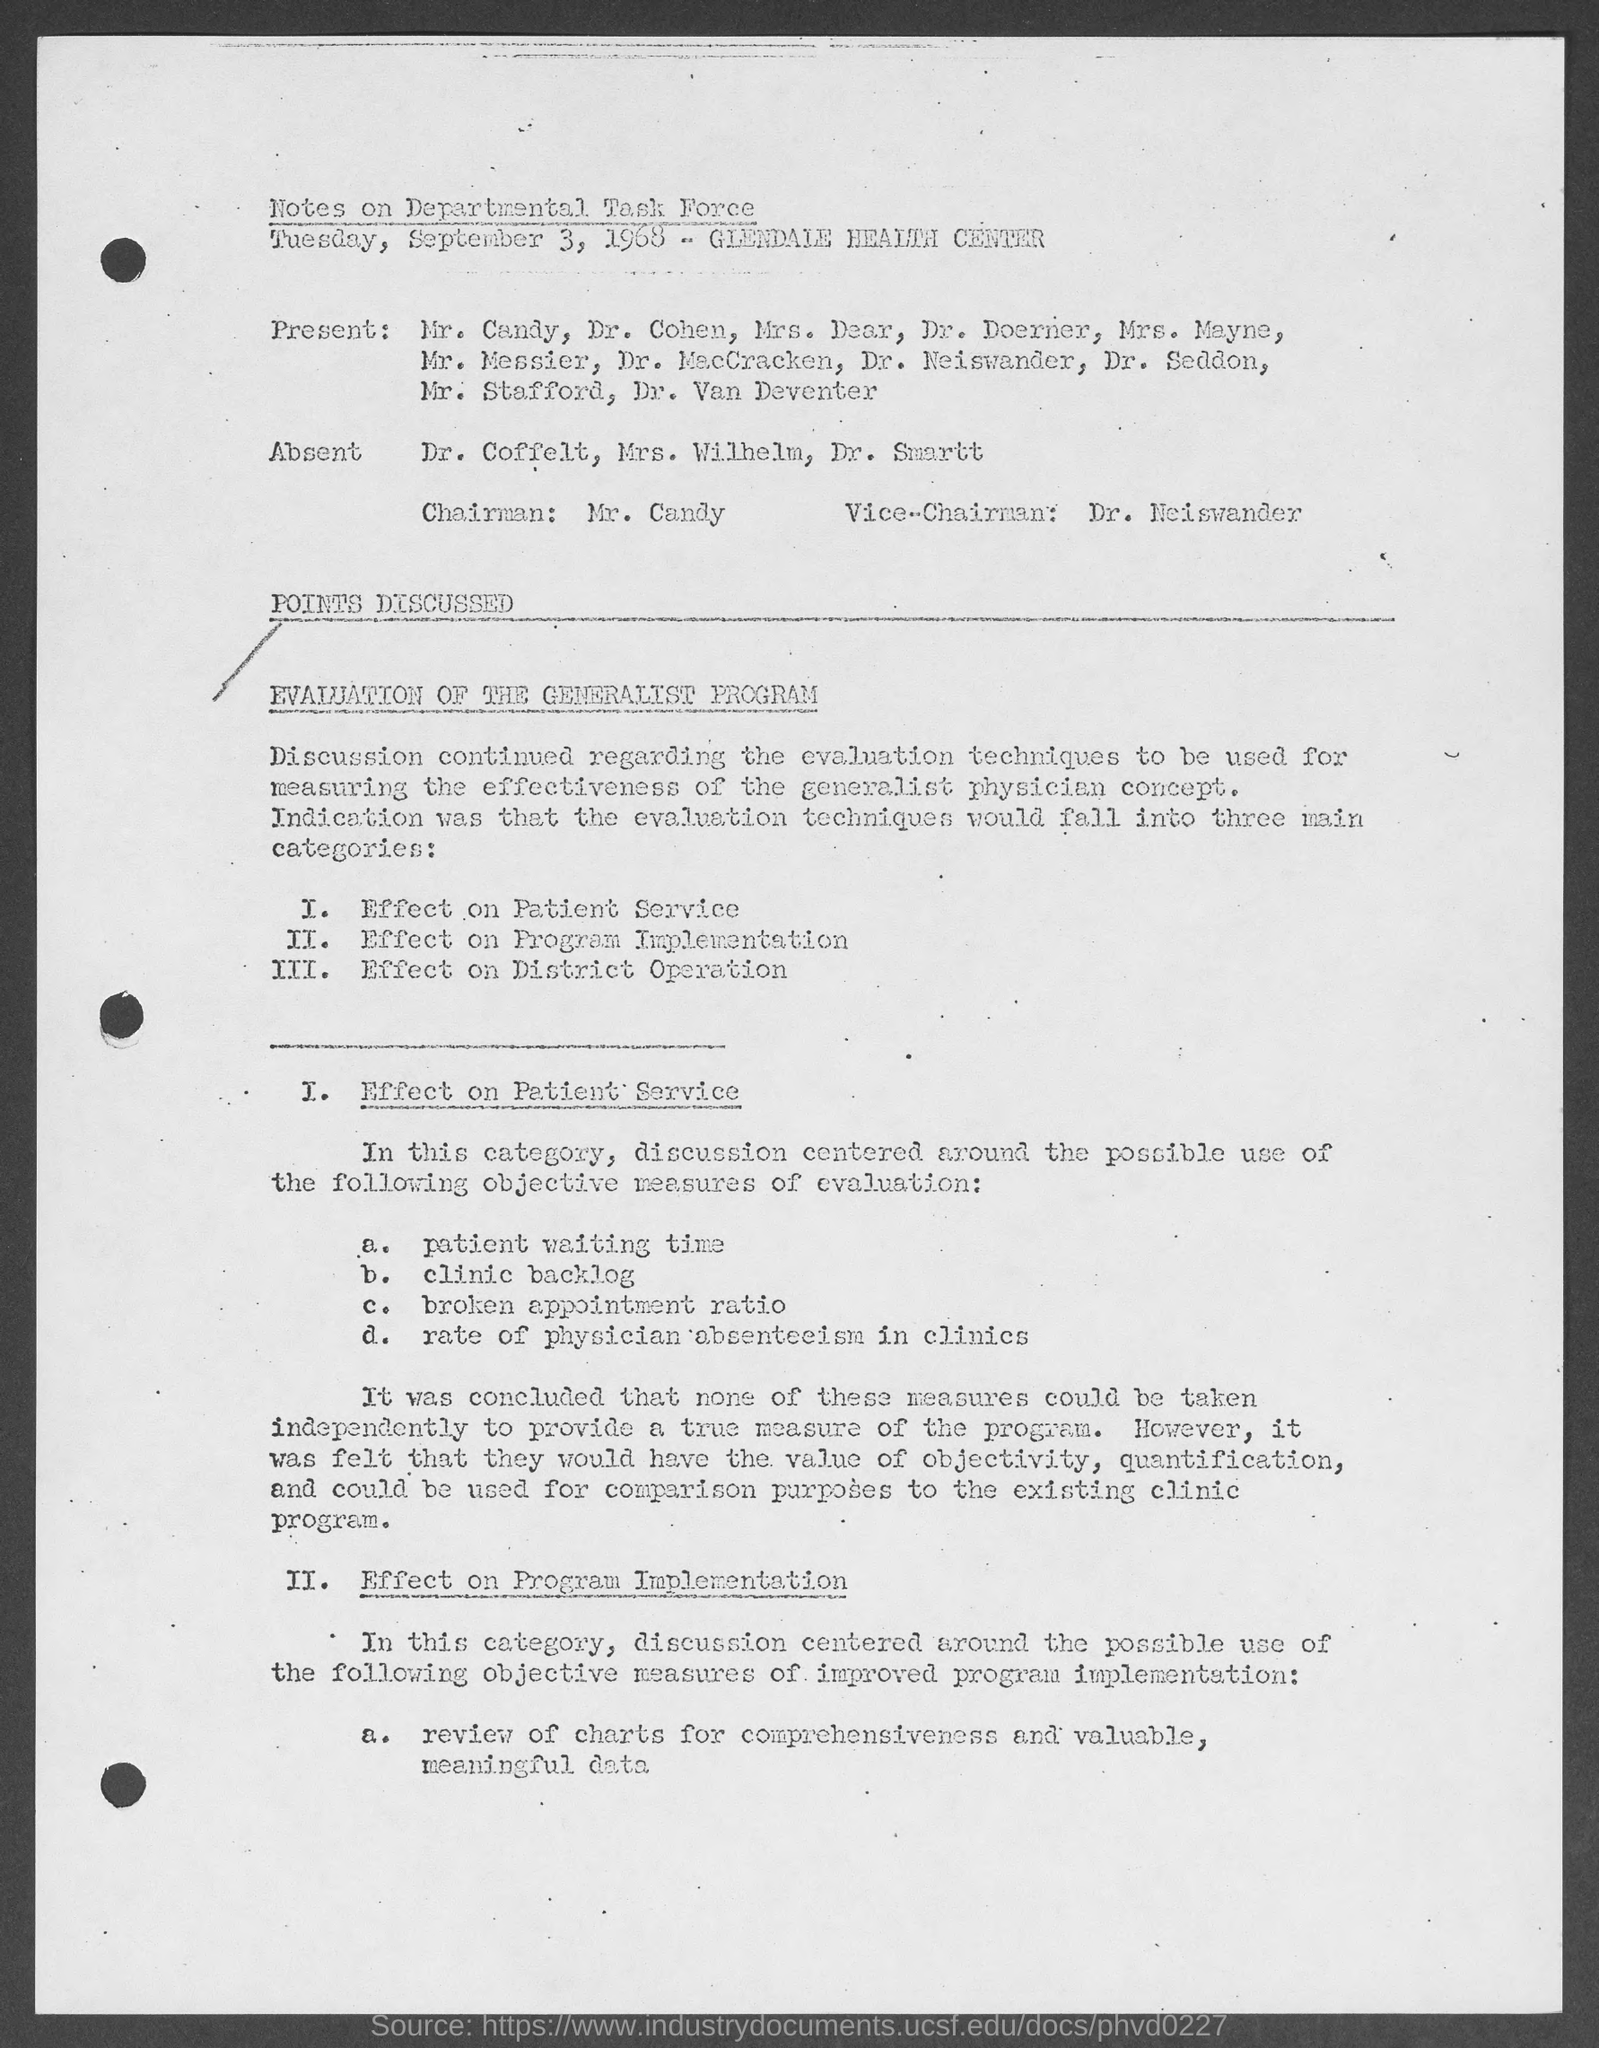What are the possible objective measures mentioned for evaluating patient services? The possible objective measures mentioned for evaluating patient service in the document include patient waiting time, clinic backlog, broken appointment ratio, and rate of physician absenteeism in clinics. However, the document also notes that these might not independently provide a true measure of the program. 